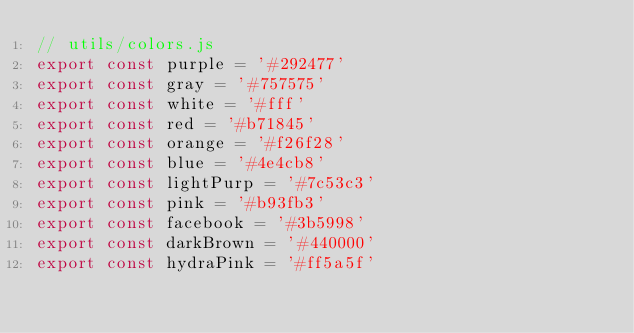Convert code to text. <code><loc_0><loc_0><loc_500><loc_500><_JavaScript_>// utils/colors.js
export const purple = '#292477'
export const gray = '#757575'
export const white = '#fff'
export const red = '#b71845'
export const orange = '#f26f28'
export const blue = '#4e4cb8'
export const lightPurp = '#7c53c3'
export const pink = '#b93fb3'
export const facebook = '#3b5998'
export const darkBrown = '#440000'
export const hydraPink = '#ff5a5f'
</code> 